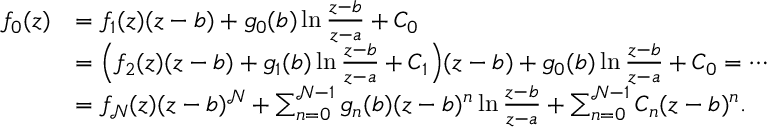<formula> <loc_0><loc_0><loc_500><loc_500>\begin{array} { r l } { f _ { 0 } ( z ) } & { = f _ { 1 } ( z ) ( z - b ) + g _ { 0 } ( b ) \ln \frac { z - b } { z - a } + C _ { 0 } } \\ & { = \left ( f _ { 2 } ( z ) ( z - b ) + g _ { 1 } ( b ) \ln \frac { z - b } { z - a } + C _ { 1 } \right ) ( z - b ) + g _ { 0 } ( b ) \ln \frac { z - b } { z - a } + C _ { 0 } = \cdots } \\ & { = f _ { \mathcal { N } } ( z ) ( z - b ) ^ { \mathcal { N } } + \sum _ { n = 0 } ^ { \mathcal { N } - 1 } g _ { n } ( b ) ( z - b ) ^ { n } \ln \frac { z - b } { z - a } + \sum _ { n = 0 } ^ { \mathcal { N } - 1 } C _ { n } ( z - b ) ^ { n } . } \end{array}</formula> 